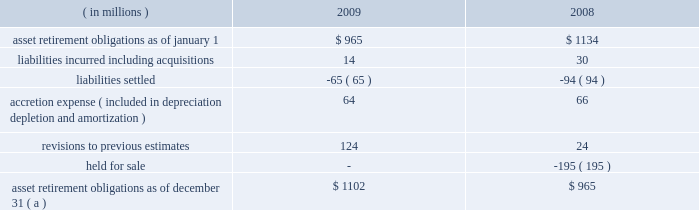Marathon oil corporation notes to consolidated financial statements ( g ) this obligation relates to a lease of equipment at united states steel 2019s clairton works cokemaking facility in pennsylvania .
We are the primary obligor under this lease .
Under the financial matters agreement , united states steel has assumed responsibility for all obligations under this lease .
This lease is an amortizing financing with a final maturity of 2012 .
( h ) these notes are senior secured notes of marathon oil canada corporation .
The notes are secured by substantially all of marathon oil canada corporation 2019s assets .
In january 2008 , we provided a full and unconditional guarantee covering the payment of all principal and interest due under the senior notes .
( i ) these obligations as of december 31 , 2009 include $ 36 million related to assets under construction at that date for which a capital lease will commence upon completion of construction .
The amounts currently reported are based upon the percent of construction completed as of december 31 , 2009 and therefore do not reflect future minimum lease obligations of $ 164 million related to the asset .
( j ) payments of long-term debt for the years 2010 - 2014 are $ 102 million , $ 246 million , $ 1492 million , $ 287 million and $ 802 million .
United steel is due to pay $ 17 million in 2010 , $ 161 million in 2011 , $ 19 million in 2012 , and $ 11 for year 2014 .
( k ) in the event of a change in control , as defined in the related agreements , debt obligations totaling $ 662 million at december 31 , 2009 , may be declared immediately due and payable .
( l ) see note 16 for information on interest rate swaps .
20 .
Asset retirement obligations the following summarizes the changes in asset retirement obligations : ( in millions ) 2009 2008 .
Asset retirement obligations as of december 31 ( a ) $ 1102 $ 965 ( a ) includes asset retirement obligation of $ 3 and $ 2 million classified as short-term at december 31 , 2009 , and 2008. .
By what percentage did asset retirement obligations increase from 2008 to 2009? 
Computations: ((1102 - 965) / 965)
Answer: 0.14197. Marathon oil corporation notes to consolidated financial statements ( g ) this obligation relates to a lease of equipment at united states steel 2019s clairton works cokemaking facility in pennsylvania .
We are the primary obligor under this lease .
Under the financial matters agreement , united states steel has assumed responsibility for all obligations under this lease .
This lease is an amortizing financing with a final maturity of 2012 .
( h ) these notes are senior secured notes of marathon oil canada corporation .
The notes are secured by substantially all of marathon oil canada corporation 2019s assets .
In january 2008 , we provided a full and unconditional guarantee covering the payment of all principal and interest due under the senior notes .
( i ) these obligations as of december 31 , 2009 include $ 36 million related to assets under construction at that date for which a capital lease will commence upon completion of construction .
The amounts currently reported are based upon the percent of construction completed as of december 31 , 2009 and therefore do not reflect future minimum lease obligations of $ 164 million related to the asset .
( j ) payments of long-term debt for the years 2010 - 2014 are $ 102 million , $ 246 million , $ 1492 million , $ 287 million and $ 802 million .
United steel is due to pay $ 17 million in 2010 , $ 161 million in 2011 , $ 19 million in 2012 , and $ 11 for year 2014 .
( k ) in the event of a change in control , as defined in the related agreements , debt obligations totaling $ 662 million at december 31 , 2009 , may be declared immediately due and payable .
( l ) see note 16 for information on interest rate swaps .
20 .
Asset retirement obligations the following summarizes the changes in asset retirement obligations : ( in millions ) 2009 2008 .
Asset retirement obligations as of december 31 ( a ) $ 1102 $ 965 ( a ) includes asset retirement obligation of $ 3 and $ 2 million classified as short-term at december 31 , 2009 , and 2008. .
By what percentage did asset retirement obligations decrease from 2007 to 2008? 
Computations: ((965 - 1134) / 1134)
Answer: -0.14903. Marathon oil corporation notes to consolidated financial statements ( g ) this obligation relates to a lease of equipment at united states steel 2019s clairton works cokemaking facility in pennsylvania .
We are the primary obligor under this lease .
Under the financial matters agreement , united states steel has assumed responsibility for all obligations under this lease .
This lease is an amortizing financing with a final maturity of 2012 .
( h ) these notes are senior secured notes of marathon oil canada corporation .
The notes are secured by substantially all of marathon oil canada corporation 2019s assets .
In january 2008 , we provided a full and unconditional guarantee covering the payment of all principal and interest due under the senior notes .
( i ) these obligations as of december 31 , 2009 include $ 36 million related to assets under construction at that date for which a capital lease will commence upon completion of construction .
The amounts currently reported are based upon the percent of construction completed as of december 31 , 2009 and therefore do not reflect future minimum lease obligations of $ 164 million related to the asset .
( j ) payments of long-term debt for the years 2010 - 2014 are $ 102 million , $ 246 million , $ 1492 million , $ 287 million and $ 802 million .
United steel is due to pay $ 17 million in 2010 , $ 161 million in 2011 , $ 19 million in 2012 , and $ 11 for year 2014 .
( k ) in the event of a change in control , as defined in the related agreements , debt obligations totaling $ 662 million at december 31 , 2009 , may be declared immediately due and payable .
( l ) see note 16 for information on interest rate swaps .
20 .
Asset retirement obligations the following summarizes the changes in asset retirement obligations : ( in millions ) 2009 2008 .
Asset retirement obligations as of december 31 ( a ) $ 1102 $ 965 ( a ) includes asset retirement obligation of $ 3 and $ 2 million classified as short-term at december 31 , 2009 , and 2008. .
What were total payments of long-term debt for the years 2010 - 2014 , in $ millions? 
Computations: ((((102 + 246) + 1492) + 287) + 802)
Answer: 2929.0. 